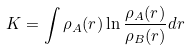<formula> <loc_0><loc_0><loc_500><loc_500>K = \int \rho _ { A } ( { r } ) \ln \frac { \rho _ { A } ( { r } ) } { \rho _ { B } ( { r } ) } d { r }</formula> 